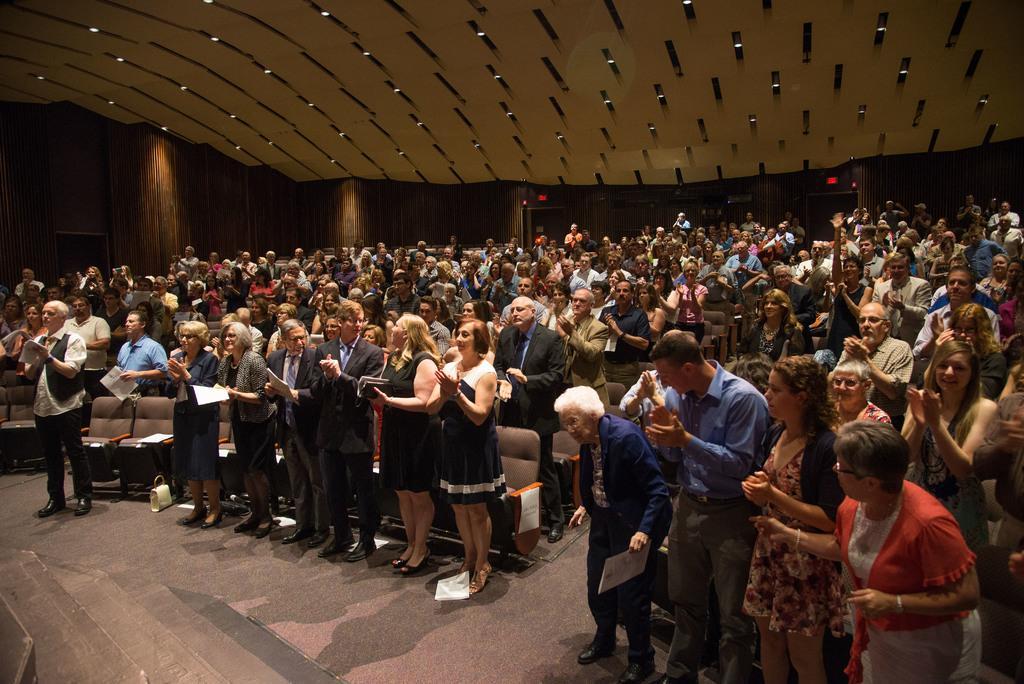Could you give a brief overview of what you see in this image? In this picture we can see some people are standing and clapping, some of them are holding papers, we can see chairs in the front, there are some lights at the top of the picture. 